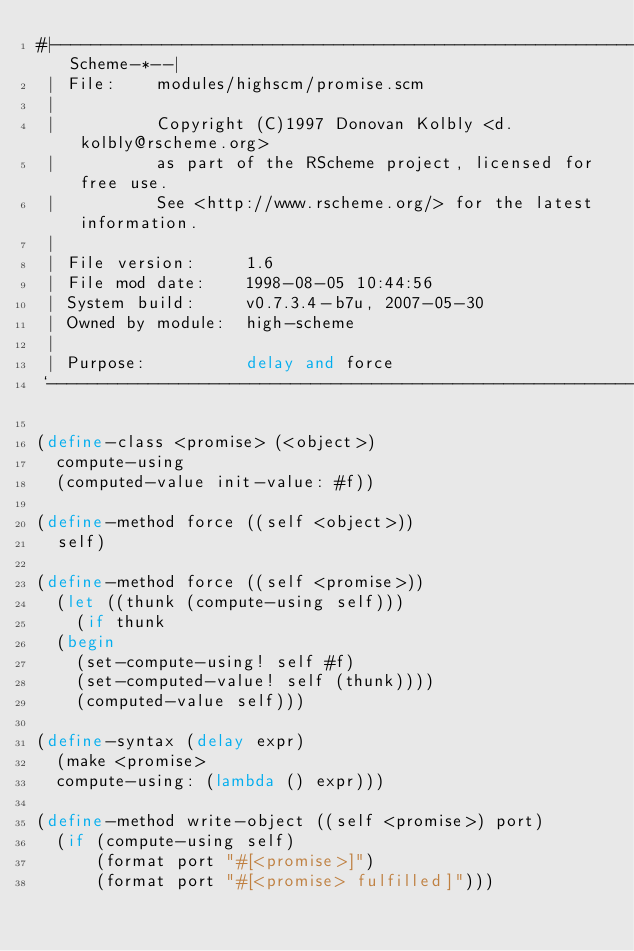Convert code to text. <code><loc_0><loc_0><loc_500><loc_500><_Scheme_>#|------------------------------------------------------------*-Scheme-*--|
 | File:    modules/highscm/promise.scm
 |
 |          Copyright (C)1997 Donovan Kolbly <d.kolbly@rscheme.org>
 |          as part of the RScheme project, licensed for free use.
 |          See <http://www.rscheme.org/> for the latest information.
 |
 | File version:     1.6
 | File mod date:    1998-08-05 10:44:56
 | System build:     v0.7.3.4-b7u, 2007-05-30
 | Owned by module:  high-scheme
 |
 | Purpose:          delay and force
 `------------------------------------------------------------------------|#

(define-class <promise> (<object>)
  compute-using
  (computed-value init-value: #f))

(define-method force ((self <object>))
  self)

(define-method force ((self <promise>))
  (let ((thunk (compute-using self)))
    (if thunk
	(begin
	  (set-compute-using! self #f)
	  (set-computed-value! self (thunk))))
    (computed-value self)))

(define-syntax (delay expr)
  (make <promise>
	compute-using: (lambda () expr)))

(define-method write-object ((self <promise>) port)
  (if (compute-using self)
      (format port "#[<promise>]")
      (format port "#[<promise> fulfilled]")))
</code> 